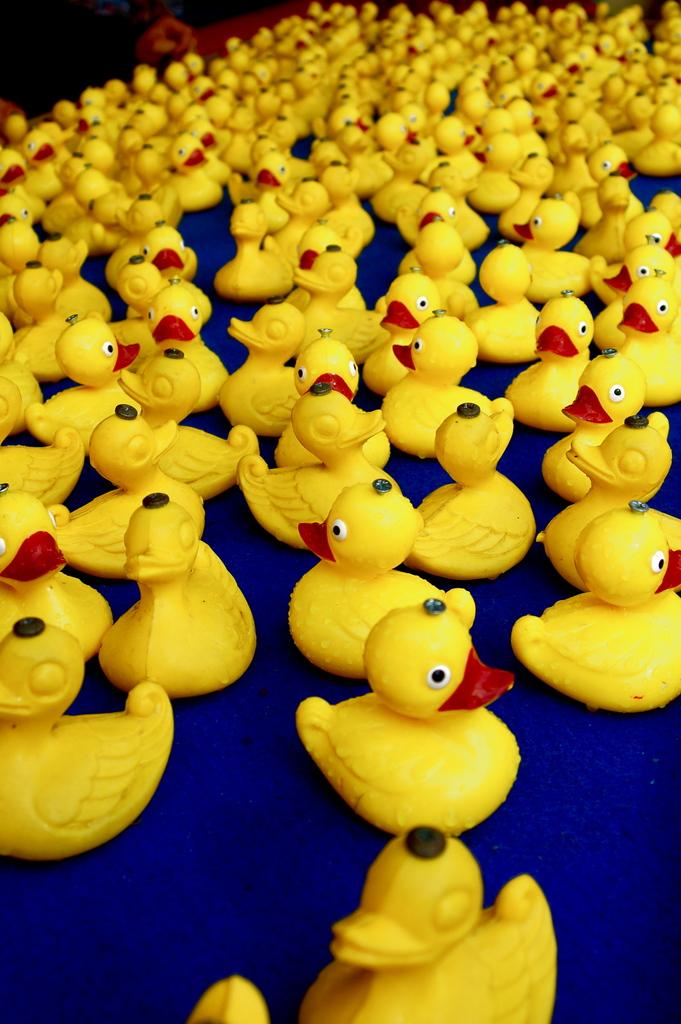What type of toys are present on the table in the image? There are so many duck toys on the table. Can you describe the arrangement of the toys on the table? The provided fact does not give specific details about the arrangement of the toys, so we cannot answer that question definitively. What type of bucket is being used for the discussion in the image? There is no bucket or discussion present in the image; it features duck toys on a table. How many hands are visible in the image? There is no mention of hands in the provided fact, so we cannot answer that question definitively. 